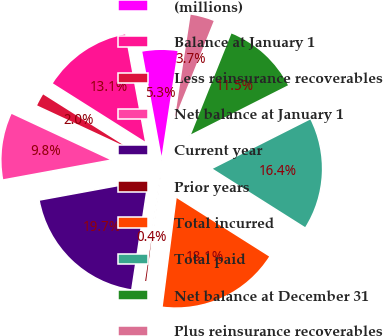<chart> <loc_0><loc_0><loc_500><loc_500><pie_chart><fcel>(millions)<fcel>Balance at January 1<fcel>Less reinsurance recoverables<fcel>Net balance at January 1<fcel>Current year<fcel>Prior years<fcel>Total incurred<fcel>Total paid<fcel>Net balance at December 31<fcel>Plus reinsurance recoverables<nl><fcel>5.31%<fcel>13.13%<fcel>2.02%<fcel>9.84%<fcel>19.71%<fcel>0.37%<fcel>18.06%<fcel>16.42%<fcel>11.49%<fcel>3.66%<nl></chart> 